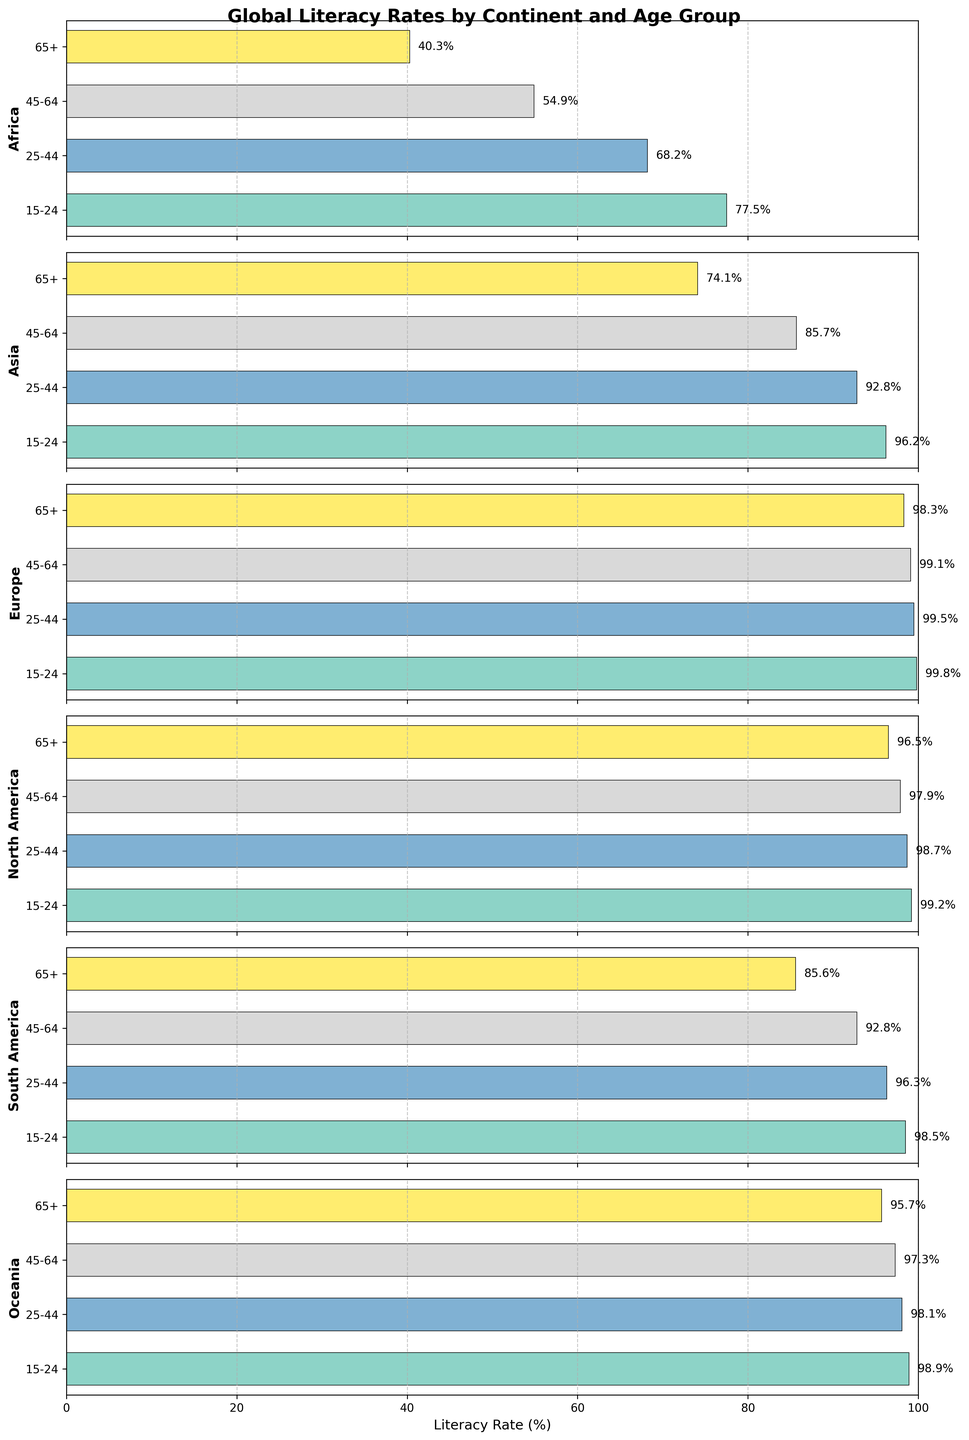What is the title of the figure? The title of the figure is usually found at the top, and in this case, it reads "Global Literacy Rates by Continent and Age Group".
Answer: Global Literacy Rates by Continent and Age Group Which continent has the highest literacy rate for the 15-24 age group? By scanning the horizontal bars corresponding to the 15-24 age group across all continents, Europe has the highest literacy rate at 99.8%.
Answer: Europe How does the literacy rate for the 65+ age group in South America compare to that in Asia? Compare the height of the bars for the 65+ age group between South America (85.6%) and Asia (74.1%). South America has a higher literacy rate for this age group.
Answer: South America has a higher rate What is the average literacy rate for the 25-44 age group across all continents? Calculate the average by summing the literacy rates for the 25-44 age group for all continents (68.2 + 92.8 + 99.5 + 98.7 + 96.3 + 98.1) and then divide by 6. (68.2 + 92.8 + 99.5 + 98.7 + 96.3 + 98.1) / 6 =  92.93
Answer: 92.93% Which age group shows the largest literacy rate difference between Africa and Oceania? Review the difference in literacy rates between Africa and Oceania for each age group: 15-24 (21.4%), 25-44 (29.9%), 45-64 (42.4%), 65+ (55.4%). The largest difference is in the 65+ age group.
Answer: 65+ What is the total number of data points displayed in the figure? Each continent has four age groups represented as separate bars. With six continents and four age groups per continent, there are 6 * 4 = 24 data points in total.
Answer: 24 Which continent has the most consistent literacy rates across all age groups? Check the uniformity of the bars' lengths across age groups for each continent. Europe shows the least variation, with rates between 98.3% and 99.8%.
Answer: Europe How much higher is the literacy rate for the 45-64 age group in North America compared to Africa? Find the literacy rates for the 45-64 age group in North America (97.9%) and Africa (54.9%) and calculate the difference: 97.9% - 54.9% = 43%.
Answer: 43% Which age group has the lowest literacy rate in Asia? Look at the bars for Asia and find the one with the smallest value. The 65+ age group has the lowest literacy rate at 74.1%.
Answer: 65+ Is there any age group where the literacy rate in Africa exceeds that in another continent? Compare the literacy rates for each age group in Africa against other continents. For all age groups, Africa does not exceed any other continent's literacy rates.
Answer: No 